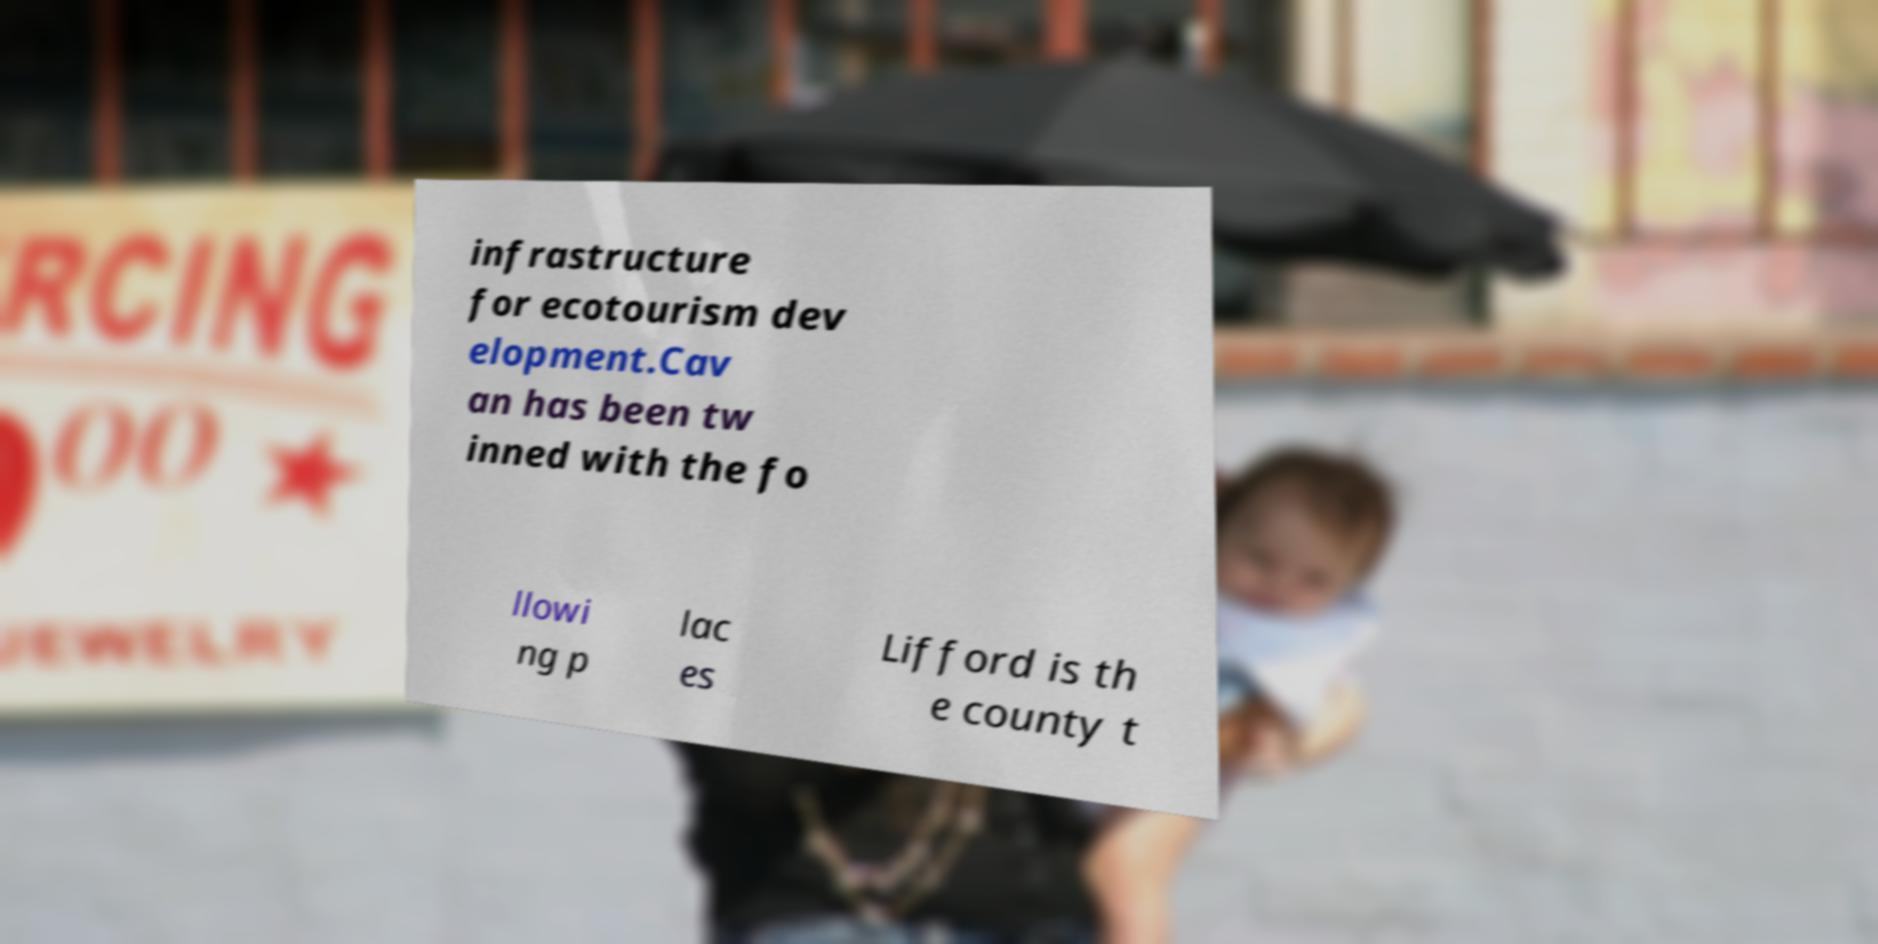Can you accurately transcribe the text from the provided image for me? infrastructure for ecotourism dev elopment.Cav an has been tw inned with the fo llowi ng p lac es Lifford is th e county t 